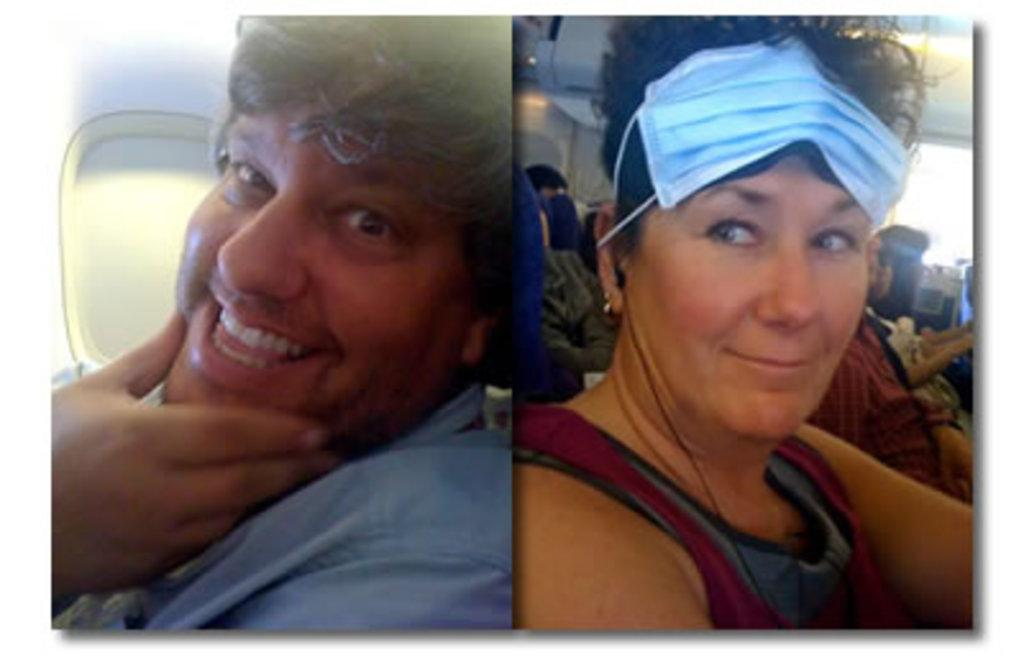What type of artwork is the image? The image is a collage. What activity are the people in the image engaged in? The people in the image are sitting on an airplane. Can you describe the windows in the image? There are windows on both the right and left sides of the image. What type of gun is being used by the person sitting on the airplane in the image? There is no gun present in the image; the people are sitting on an airplane. 